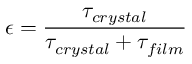Convert formula to latex. <formula><loc_0><loc_0><loc_500><loc_500>\epsilon = \frac { \tau _ { c r y s t a l } } { \tau _ { c r y s t a l } + \tau _ { f i l m } }</formula> 